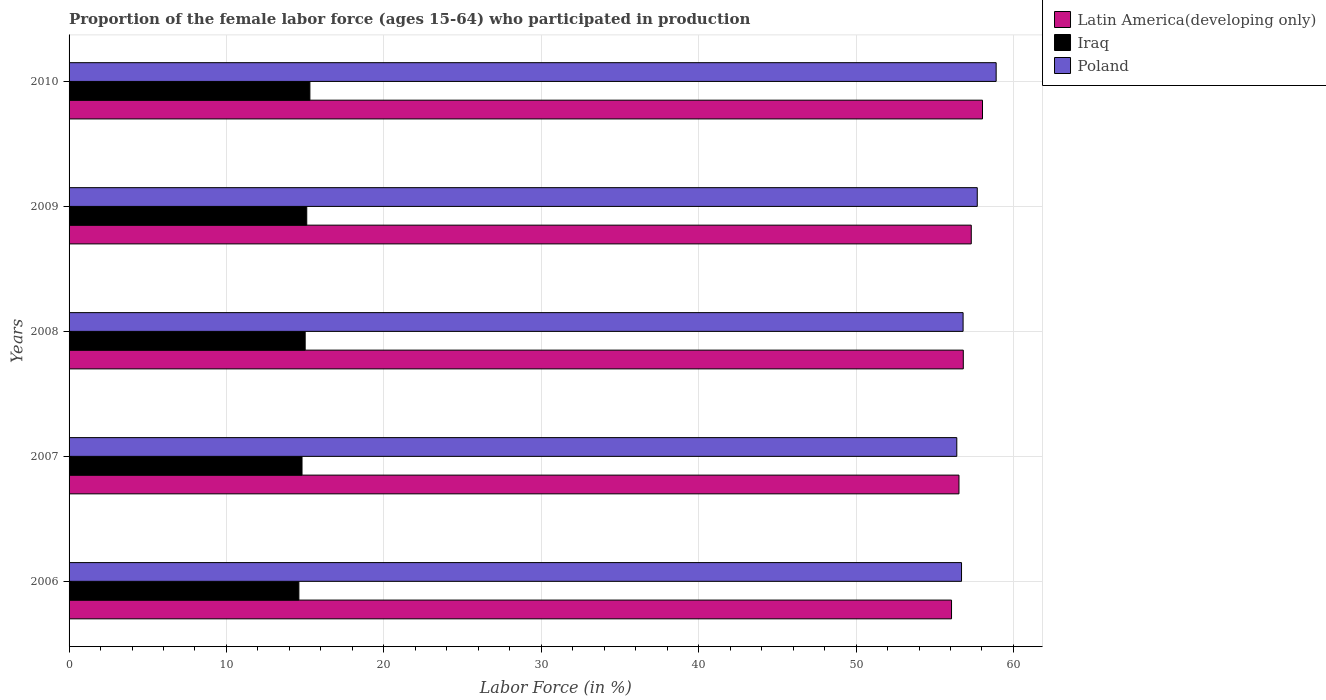How many different coloured bars are there?
Keep it short and to the point. 3. Are the number of bars on each tick of the Y-axis equal?
Give a very brief answer. Yes. How many bars are there on the 5th tick from the top?
Provide a short and direct response. 3. How many bars are there on the 4th tick from the bottom?
Keep it short and to the point. 3. What is the label of the 1st group of bars from the top?
Ensure brevity in your answer.  2010. What is the proportion of the female labor force who participated in production in Latin America(developing only) in 2010?
Keep it short and to the point. 58.03. Across all years, what is the maximum proportion of the female labor force who participated in production in Poland?
Give a very brief answer. 58.9. Across all years, what is the minimum proportion of the female labor force who participated in production in Latin America(developing only)?
Your response must be concise. 56.07. What is the total proportion of the female labor force who participated in production in Iraq in the graph?
Offer a terse response. 74.8. What is the difference between the proportion of the female labor force who participated in production in Iraq in 2006 and that in 2009?
Ensure brevity in your answer.  -0.5. What is the difference between the proportion of the female labor force who participated in production in Poland in 2006 and the proportion of the female labor force who participated in production in Iraq in 2008?
Offer a very short reply. 41.7. What is the average proportion of the female labor force who participated in production in Latin America(developing only) per year?
Make the answer very short. 56.95. In the year 2007, what is the difference between the proportion of the female labor force who participated in production in Poland and proportion of the female labor force who participated in production in Latin America(developing only)?
Give a very brief answer. -0.14. What is the ratio of the proportion of the female labor force who participated in production in Poland in 2007 to that in 2010?
Offer a terse response. 0.96. Is the proportion of the female labor force who participated in production in Latin America(developing only) in 2009 less than that in 2010?
Give a very brief answer. Yes. Is the difference between the proportion of the female labor force who participated in production in Poland in 2007 and 2008 greater than the difference between the proportion of the female labor force who participated in production in Latin America(developing only) in 2007 and 2008?
Your answer should be compact. No. What is the difference between the highest and the second highest proportion of the female labor force who participated in production in Poland?
Offer a terse response. 1.2. What is the difference between the highest and the lowest proportion of the female labor force who participated in production in Latin America(developing only)?
Your answer should be very brief. 1.97. In how many years, is the proportion of the female labor force who participated in production in Iraq greater than the average proportion of the female labor force who participated in production in Iraq taken over all years?
Ensure brevity in your answer.  3. What does the 2nd bar from the top in 2006 represents?
Your response must be concise. Iraq. What does the 1st bar from the bottom in 2006 represents?
Your response must be concise. Latin America(developing only). Is it the case that in every year, the sum of the proportion of the female labor force who participated in production in Latin America(developing only) and proportion of the female labor force who participated in production in Iraq is greater than the proportion of the female labor force who participated in production in Poland?
Offer a terse response. Yes. How many years are there in the graph?
Offer a very short reply. 5. What is the difference between two consecutive major ticks on the X-axis?
Provide a succinct answer. 10. Does the graph contain any zero values?
Your answer should be compact. No. How many legend labels are there?
Provide a succinct answer. 3. How are the legend labels stacked?
Your response must be concise. Vertical. What is the title of the graph?
Your answer should be compact. Proportion of the female labor force (ages 15-64) who participated in production. Does "Norway" appear as one of the legend labels in the graph?
Offer a terse response. No. What is the label or title of the Y-axis?
Your answer should be compact. Years. What is the Labor Force (in %) of Latin America(developing only) in 2006?
Provide a succinct answer. 56.07. What is the Labor Force (in %) of Iraq in 2006?
Your answer should be very brief. 14.6. What is the Labor Force (in %) in Poland in 2006?
Offer a very short reply. 56.7. What is the Labor Force (in %) in Latin America(developing only) in 2007?
Your answer should be very brief. 56.54. What is the Labor Force (in %) of Iraq in 2007?
Keep it short and to the point. 14.8. What is the Labor Force (in %) of Poland in 2007?
Provide a succinct answer. 56.4. What is the Labor Force (in %) of Latin America(developing only) in 2008?
Your answer should be very brief. 56.81. What is the Labor Force (in %) of Poland in 2008?
Offer a very short reply. 56.8. What is the Labor Force (in %) of Latin America(developing only) in 2009?
Offer a very short reply. 57.32. What is the Labor Force (in %) of Iraq in 2009?
Ensure brevity in your answer.  15.1. What is the Labor Force (in %) of Poland in 2009?
Provide a short and direct response. 57.7. What is the Labor Force (in %) in Latin America(developing only) in 2010?
Your answer should be compact. 58.03. What is the Labor Force (in %) in Iraq in 2010?
Provide a short and direct response. 15.3. What is the Labor Force (in %) of Poland in 2010?
Offer a terse response. 58.9. Across all years, what is the maximum Labor Force (in %) in Latin America(developing only)?
Offer a very short reply. 58.03. Across all years, what is the maximum Labor Force (in %) in Iraq?
Your answer should be compact. 15.3. Across all years, what is the maximum Labor Force (in %) of Poland?
Your response must be concise. 58.9. Across all years, what is the minimum Labor Force (in %) in Latin America(developing only)?
Offer a terse response. 56.07. Across all years, what is the minimum Labor Force (in %) in Iraq?
Keep it short and to the point. 14.6. Across all years, what is the minimum Labor Force (in %) of Poland?
Your answer should be very brief. 56.4. What is the total Labor Force (in %) of Latin America(developing only) in the graph?
Your answer should be very brief. 284.77. What is the total Labor Force (in %) of Iraq in the graph?
Provide a succinct answer. 74.8. What is the total Labor Force (in %) in Poland in the graph?
Your answer should be compact. 286.5. What is the difference between the Labor Force (in %) of Latin America(developing only) in 2006 and that in 2007?
Your answer should be compact. -0.47. What is the difference between the Labor Force (in %) in Latin America(developing only) in 2006 and that in 2008?
Provide a succinct answer. -0.75. What is the difference between the Labor Force (in %) of Iraq in 2006 and that in 2008?
Your response must be concise. -0.4. What is the difference between the Labor Force (in %) of Latin America(developing only) in 2006 and that in 2009?
Provide a succinct answer. -1.25. What is the difference between the Labor Force (in %) in Iraq in 2006 and that in 2009?
Your answer should be compact. -0.5. What is the difference between the Labor Force (in %) in Poland in 2006 and that in 2009?
Give a very brief answer. -1. What is the difference between the Labor Force (in %) in Latin America(developing only) in 2006 and that in 2010?
Your answer should be compact. -1.97. What is the difference between the Labor Force (in %) of Iraq in 2006 and that in 2010?
Your answer should be very brief. -0.7. What is the difference between the Labor Force (in %) in Poland in 2006 and that in 2010?
Ensure brevity in your answer.  -2.2. What is the difference between the Labor Force (in %) of Latin America(developing only) in 2007 and that in 2008?
Provide a short and direct response. -0.28. What is the difference between the Labor Force (in %) in Poland in 2007 and that in 2008?
Your answer should be very brief. -0.4. What is the difference between the Labor Force (in %) in Latin America(developing only) in 2007 and that in 2009?
Offer a terse response. -0.78. What is the difference between the Labor Force (in %) of Iraq in 2007 and that in 2009?
Your answer should be very brief. -0.3. What is the difference between the Labor Force (in %) in Poland in 2007 and that in 2009?
Your response must be concise. -1.3. What is the difference between the Labor Force (in %) of Latin America(developing only) in 2007 and that in 2010?
Make the answer very short. -1.49. What is the difference between the Labor Force (in %) in Latin America(developing only) in 2008 and that in 2009?
Your answer should be very brief. -0.51. What is the difference between the Labor Force (in %) in Latin America(developing only) in 2008 and that in 2010?
Provide a short and direct response. -1.22. What is the difference between the Labor Force (in %) in Latin America(developing only) in 2009 and that in 2010?
Your response must be concise. -0.71. What is the difference between the Labor Force (in %) in Latin America(developing only) in 2006 and the Labor Force (in %) in Iraq in 2007?
Your answer should be very brief. 41.27. What is the difference between the Labor Force (in %) of Latin America(developing only) in 2006 and the Labor Force (in %) of Poland in 2007?
Your answer should be very brief. -0.33. What is the difference between the Labor Force (in %) in Iraq in 2006 and the Labor Force (in %) in Poland in 2007?
Your answer should be very brief. -41.8. What is the difference between the Labor Force (in %) of Latin America(developing only) in 2006 and the Labor Force (in %) of Iraq in 2008?
Offer a terse response. 41.07. What is the difference between the Labor Force (in %) in Latin America(developing only) in 2006 and the Labor Force (in %) in Poland in 2008?
Your answer should be compact. -0.73. What is the difference between the Labor Force (in %) in Iraq in 2006 and the Labor Force (in %) in Poland in 2008?
Make the answer very short. -42.2. What is the difference between the Labor Force (in %) of Latin America(developing only) in 2006 and the Labor Force (in %) of Iraq in 2009?
Provide a short and direct response. 40.97. What is the difference between the Labor Force (in %) of Latin America(developing only) in 2006 and the Labor Force (in %) of Poland in 2009?
Give a very brief answer. -1.63. What is the difference between the Labor Force (in %) of Iraq in 2006 and the Labor Force (in %) of Poland in 2009?
Your answer should be compact. -43.1. What is the difference between the Labor Force (in %) in Latin America(developing only) in 2006 and the Labor Force (in %) in Iraq in 2010?
Offer a terse response. 40.77. What is the difference between the Labor Force (in %) of Latin America(developing only) in 2006 and the Labor Force (in %) of Poland in 2010?
Make the answer very short. -2.83. What is the difference between the Labor Force (in %) in Iraq in 2006 and the Labor Force (in %) in Poland in 2010?
Your answer should be very brief. -44.3. What is the difference between the Labor Force (in %) in Latin America(developing only) in 2007 and the Labor Force (in %) in Iraq in 2008?
Make the answer very short. 41.54. What is the difference between the Labor Force (in %) of Latin America(developing only) in 2007 and the Labor Force (in %) of Poland in 2008?
Keep it short and to the point. -0.26. What is the difference between the Labor Force (in %) in Iraq in 2007 and the Labor Force (in %) in Poland in 2008?
Keep it short and to the point. -42. What is the difference between the Labor Force (in %) of Latin America(developing only) in 2007 and the Labor Force (in %) of Iraq in 2009?
Your answer should be very brief. 41.44. What is the difference between the Labor Force (in %) in Latin America(developing only) in 2007 and the Labor Force (in %) in Poland in 2009?
Offer a terse response. -1.16. What is the difference between the Labor Force (in %) of Iraq in 2007 and the Labor Force (in %) of Poland in 2009?
Provide a short and direct response. -42.9. What is the difference between the Labor Force (in %) of Latin America(developing only) in 2007 and the Labor Force (in %) of Iraq in 2010?
Ensure brevity in your answer.  41.24. What is the difference between the Labor Force (in %) in Latin America(developing only) in 2007 and the Labor Force (in %) in Poland in 2010?
Provide a short and direct response. -2.36. What is the difference between the Labor Force (in %) in Iraq in 2007 and the Labor Force (in %) in Poland in 2010?
Give a very brief answer. -44.1. What is the difference between the Labor Force (in %) in Latin America(developing only) in 2008 and the Labor Force (in %) in Iraq in 2009?
Make the answer very short. 41.71. What is the difference between the Labor Force (in %) of Latin America(developing only) in 2008 and the Labor Force (in %) of Poland in 2009?
Provide a short and direct response. -0.89. What is the difference between the Labor Force (in %) in Iraq in 2008 and the Labor Force (in %) in Poland in 2009?
Provide a succinct answer. -42.7. What is the difference between the Labor Force (in %) of Latin America(developing only) in 2008 and the Labor Force (in %) of Iraq in 2010?
Offer a very short reply. 41.51. What is the difference between the Labor Force (in %) in Latin America(developing only) in 2008 and the Labor Force (in %) in Poland in 2010?
Offer a very short reply. -2.09. What is the difference between the Labor Force (in %) in Iraq in 2008 and the Labor Force (in %) in Poland in 2010?
Provide a short and direct response. -43.9. What is the difference between the Labor Force (in %) of Latin America(developing only) in 2009 and the Labor Force (in %) of Iraq in 2010?
Provide a short and direct response. 42.02. What is the difference between the Labor Force (in %) of Latin America(developing only) in 2009 and the Labor Force (in %) of Poland in 2010?
Provide a succinct answer. -1.58. What is the difference between the Labor Force (in %) in Iraq in 2009 and the Labor Force (in %) in Poland in 2010?
Ensure brevity in your answer.  -43.8. What is the average Labor Force (in %) in Latin America(developing only) per year?
Make the answer very short. 56.95. What is the average Labor Force (in %) of Iraq per year?
Offer a terse response. 14.96. What is the average Labor Force (in %) in Poland per year?
Your response must be concise. 57.3. In the year 2006, what is the difference between the Labor Force (in %) of Latin America(developing only) and Labor Force (in %) of Iraq?
Your response must be concise. 41.47. In the year 2006, what is the difference between the Labor Force (in %) of Latin America(developing only) and Labor Force (in %) of Poland?
Keep it short and to the point. -0.63. In the year 2006, what is the difference between the Labor Force (in %) of Iraq and Labor Force (in %) of Poland?
Your answer should be compact. -42.1. In the year 2007, what is the difference between the Labor Force (in %) in Latin America(developing only) and Labor Force (in %) in Iraq?
Your response must be concise. 41.74. In the year 2007, what is the difference between the Labor Force (in %) in Latin America(developing only) and Labor Force (in %) in Poland?
Give a very brief answer. 0.14. In the year 2007, what is the difference between the Labor Force (in %) in Iraq and Labor Force (in %) in Poland?
Your answer should be compact. -41.6. In the year 2008, what is the difference between the Labor Force (in %) in Latin America(developing only) and Labor Force (in %) in Iraq?
Your response must be concise. 41.81. In the year 2008, what is the difference between the Labor Force (in %) of Latin America(developing only) and Labor Force (in %) of Poland?
Your answer should be compact. 0.01. In the year 2008, what is the difference between the Labor Force (in %) of Iraq and Labor Force (in %) of Poland?
Provide a short and direct response. -41.8. In the year 2009, what is the difference between the Labor Force (in %) of Latin America(developing only) and Labor Force (in %) of Iraq?
Offer a terse response. 42.22. In the year 2009, what is the difference between the Labor Force (in %) of Latin America(developing only) and Labor Force (in %) of Poland?
Provide a succinct answer. -0.38. In the year 2009, what is the difference between the Labor Force (in %) of Iraq and Labor Force (in %) of Poland?
Your response must be concise. -42.6. In the year 2010, what is the difference between the Labor Force (in %) of Latin America(developing only) and Labor Force (in %) of Iraq?
Make the answer very short. 42.73. In the year 2010, what is the difference between the Labor Force (in %) in Latin America(developing only) and Labor Force (in %) in Poland?
Make the answer very short. -0.87. In the year 2010, what is the difference between the Labor Force (in %) in Iraq and Labor Force (in %) in Poland?
Your response must be concise. -43.6. What is the ratio of the Labor Force (in %) of Iraq in 2006 to that in 2007?
Make the answer very short. 0.99. What is the ratio of the Labor Force (in %) in Poland in 2006 to that in 2007?
Your answer should be compact. 1.01. What is the ratio of the Labor Force (in %) in Iraq in 2006 to that in 2008?
Your answer should be compact. 0.97. What is the ratio of the Labor Force (in %) of Poland in 2006 to that in 2008?
Provide a succinct answer. 1. What is the ratio of the Labor Force (in %) in Latin America(developing only) in 2006 to that in 2009?
Offer a terse response. 0.98. What is the ratio of the Labor Force (in %) in Iraq in 2006 to that in 2009?
Ensure brevity in your answer.  0.97. What is the ratio of the Labor Force (in %) in Poland in 2006 to that in 2009?
Provide a succinct answer. 0.98. What is the ratio of the Labor Force (in %) of Latin America(developing only) in 2006 to that in 2010?
Your response must be concise. 0.97. What is the ratio of the Labor Force (in %) in Iraq in 2006 to that in 2010?
Provide a succinct answer. 0.95. What is the ratio of the Labor Force (in %) in Poland in 2006 to that in 2010?
Offer a very short reply. 0.96. What is the ratio of the Labor Force (in %) of Iraq in 2007 to that in 2008?
Offer a terse response. 0.99. What is the ratio of the Labor Force (in %) in Latin America(developing only) in 2007 to that in 2009?
Keep it short and to the point. 0.99. What is the ratio of the Labor Force (in %) in Iraq in 2007 to that in 2009?
Give a very brief answer. 0.98. What is the ratio of the Labor Force (in %) in Poland in 2007 to that in 2009?
Provide a short and direct response. 0.98. What is the ratio of the Labor Force (in %) of Latin America(developing only) in 2007 to that in 2010?
Give a very brief answer. 0.97. What is the ratio of the Labor Force (in %) in Iraq in 2007 to that in 2010?
Provide a succinct answer. 0.97. What is the ratio of the Labor Force (in %) of Poland in 2007 to that in 2010?
Offer a very short reply. 0.96. What is the ratio of the Labor Force (in %) of Poland in 2008 to that in 2009?
Keep it short and to the point. 0.98. What is the ratio of the Labor Force (in %) in Iraq in 2008 to that in 2010?
Ensure brevity in your answer.  0.98. What is the ratio of the Labor Force (in %) in Poland in 2008 to that in 2010?
Keep it short and to the point. 0.96. What is the ratio of the Labor Force (in %) of Iraq in 2009 to that in 2010?
Make the answer very short. 0.99. What is the ratio of the Labor Force (in %) of Poland in 2009 to that in 2010?
Your answer should be compact. 0.98. What is the difference between the highest and the second highest Labor Force (in %) in Latin America(developing only)?
Provide a short and direct response. 0.71. What is the difference between the highest and the lowest Labor Force (in %) in Latin America(developing only)?
Give a very brief answer. 1.97. What is the difference between the highest and the lowest Labor Force (in %) in Iraq?
Offer a very short reply. 0.7. 